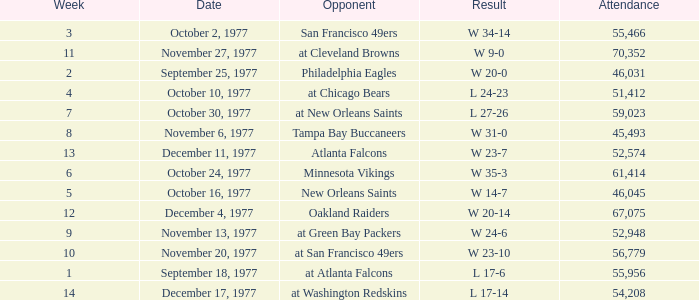I'm looking to parse the entire table for insights. Could you assist me with that? {'header': ['Week', 'Date', 'Opponent', 'Result', 'Attendance'], 'rows': [['3', 'October 2, 1977', 'San Francisco 49ers', 'W 34-14', '55,466'], ['11', 'November 27, 1977', 'at Cleveland Browns', 'W 9-0', '70,352'], ['2', 'September 25, 1977', 'Philadelphia Eagles', 'W 20-0', '46,031'], ['4', 'October 10, 1977', 'at Chicago Bears', 'L 24-23', '51,412'], ['7', 'October 30, 1977', 'at New Orleans Saints', 'L 27-26', '59,023'], ['8', 'November 6, 1977', 'Tampa Bay Buccaneers', 'W 31-0', '45,493'], ['13', 'December 11, 1977', 'Atlanta Falcons', 'W 23-7', '52,574'], ['6', 'October 24, 1977', 'Minnesota Vikings', 'W 35-3', '61,414'], ['5', 'October 16, 1977', 'New Orleans Saints', 'W 14-7', '46,045'], ['12', 'December 4, 1977', 'Oakland Raiders', 'W 20-14', '67,075'], ['9', 'November 13, 1977', 'at Green Bay Packers', 'W 24-6', '52,948'], ['10', 'November 20, 1977', 'at San Francisco 49ers', 'W 23-10', '56,779'], ['1', 'September 18, 1977', 'at Atlanta Falcons', 'L 17-6', '55,956'], ['14', 'December 17, 1977', 'at Washington Redskins', 'L 17-14', '54,208']]} What is the lowest attendance for week 2? 46031.0. 